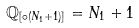<formula> <loc_0><loc_0><loc_500><loc_500>\mathbb { Q } _ { [ \circ ( N _ { 1 } + 1 ) ] } = N _ { 1 } + 1</formula> 